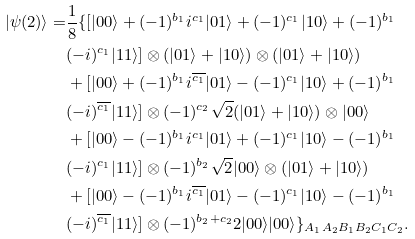Convert formula to latex. <formula><loc_0><loc_0><loc_500><loc_500>| \psi ( 2 ) \rangle = & \frac { 1 } { 8 } \{ [ | 0 0 \rangle + ( - 1 ) ^ { b _ { 1 } } i ^ { c _ { 1 } } | 0 1 \rangle + ( - 1 ) ^ { c _ { 1 } } | 1 0 \rangle + ( - 1 ) ^ { b _ { 1 } } \\ & ( - i ) ^ { c _ { 1 } } | 1 1 \rangle ] \otimes ( | 0 1 \rangle + | 1 0 \rangle ) \otimes ( | 0 1 \rangle + | 1 0 \rangle ) \\ & + [ | 0 0 \rangle + ( - 1 ) ^ { b _ { 1 } } i ^ { \overline { c _ { 1 } } } | 0 1 \rangle - ( - 1 ) ^ { c _ { 1 } } | 1 0 \rangle + ( - 1 ) ^ { b _ { 1 } } \\ & ( - i ) ^ { \overline { c _ { 1 } } } | 1 1 \rangle ] \otimes ( - 1 ) ^ { c _ { 2 } } \sqrt { 2 } ( | 0 1 \rangle + | 1 0 \rangle ) \otimes | 0 0 \rangle \\ & + [ | 0 0 \rangle - ( - 1 ) ^ { b _ { 1 } } i ^ { c _ { 1 } } | 0 1 \rangle + ( - 1 ) ^ { c _ { 1 } } | 1 0 \rangle - ( - 1 ) ^ { b _ { 1 } } \\ & ( - i ) ^ { c _ { 1 } } | 1 1 \rangle ] \otimes ( - 1 ) ^ { b _ { 2 } } \sqrt { 2 } | 0 0 \rangle \otimes ( | 0 1 \rangle + | 1 0 \rangle ) \\ & + [ | 0 0 \rangle - ( - 1 ) ^ { b _ { 1 } } i ^ { \overline { c _ { 1 } } } | 0 1 \rangle - ( - 1 ) ^ { c _ { 1 } } | 1 0 \rangle - ( - 1 ) ^ { b _ { 1 } } \\ & ( - i ) ^ { \overline { c _ { 1 } } } | 1 1 \rangle ] \otimes ( - 1 ) ^ { b _ { 2 } + c _ { 2 } } 2 | 0 0 \rangle | 0 0 \rangle \} _ { A _ { 1 } A _ { 2 } B _ { 1 } B _ { 2 } C _ { 1 } C _ { 2 } } .</formula> 